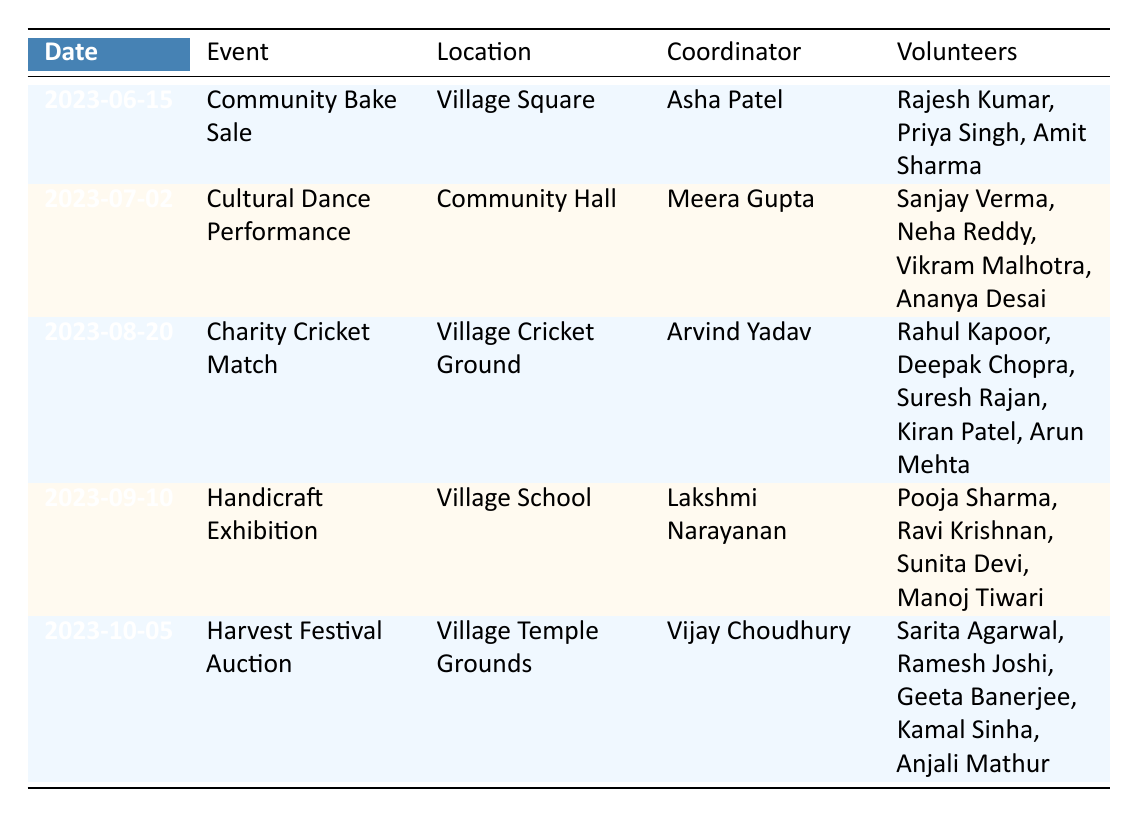What is the location of the Community Bake Sale? The table shows that the Community Bake Sale is scheduled for June 15, 2023, at the Village Square.
Answer: Village Square Who is the coordinator for the Harvest Festival Auction? According to the table, the coordinator for the Harvest Festival Auction is Vijay Choudhury.
Answer: Vijay Choudhury How many volunteers are assigned to the Cultural Dance Performance? The Cultural Dance Performance has four volunteers listed: Sanjay Verma, Neha Reddy, Vikram Malhotra, and Ananya Desai, making a total of four.
Answer: 4 Which event has the highest fundraising goal and what is that amount? By comparing the goals listed for each event, the Harvest Festival Auction has the highest goal of 12000.
Answer: 12000 Is there a volunteer named Amit Sharma? Checking the volunteer list in the table, Amit Sharma is indeed listed as a volunteer for the Community Bake Sale.
Answer: Yes What is the total fundraising goal for all events? The total fundraising goals are calculated by summing the individual goals: 5000 + 7500 + 10000 + 6000 + 12000 = 50000.
Answer: 50000 Which event takes place in August? The only event listed in August is the Charity Cricket Match, scheduled for August 20, 2023.
Answer: Charity Cricket Match Are there more than five volunteers assigned in total across all events? Counting the volunteers per event, we find that there are a total of 18 volunteers (3 + 4 + 5 + 4 + 5). Therefore, the answer is yes.
Answer: Yes What is the difference in fundraising goals between the Handicraft Exhibition and the Cultural Dance Performance? The goal for the Handicraft Exhibition is 6000, and for the Cultural Dance Performance, it is 7500. Calculating the difference: 7500 - 6000 = 1500.
Answer: 1500 